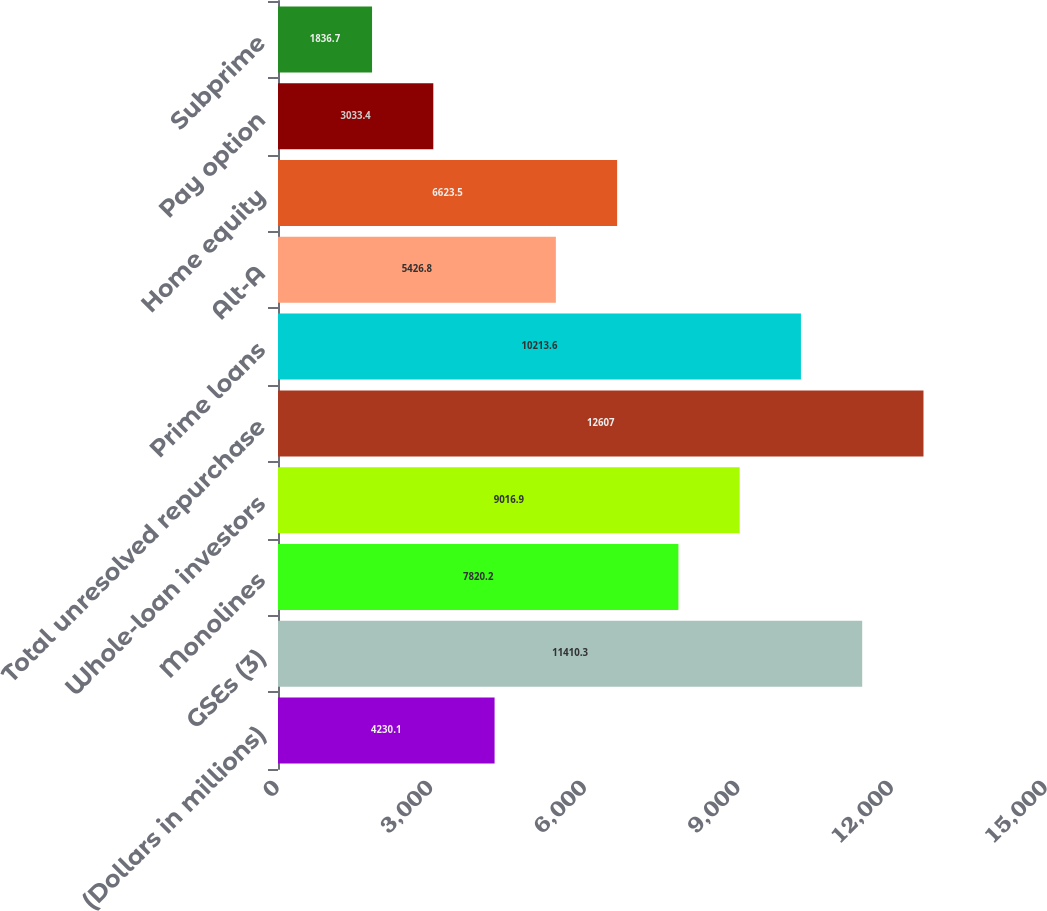Convert chart to OTSL. <chart><loc_0><loc_0><loc_500><loc_500><bar_chart><fcel>(Dollars in millions)<fcel>GSEs (3)<fcel>Monolines<fcel>Whole-loan investors<fcel>Total unresolved repurchase<fcel>Prime loans<fcel>Alt-A<fcel>Home equity<fcel>Pay option<fcel>Subprime<nl><fcel>4230.1<fcel>11410.3<fcel>7820.2<fcel>9016.9<fcel>12607<fcel>10213.6<fcel>5426.8<fcel>6623.5<fcel>3033.4<fcel>1836.7<nl></chart> 